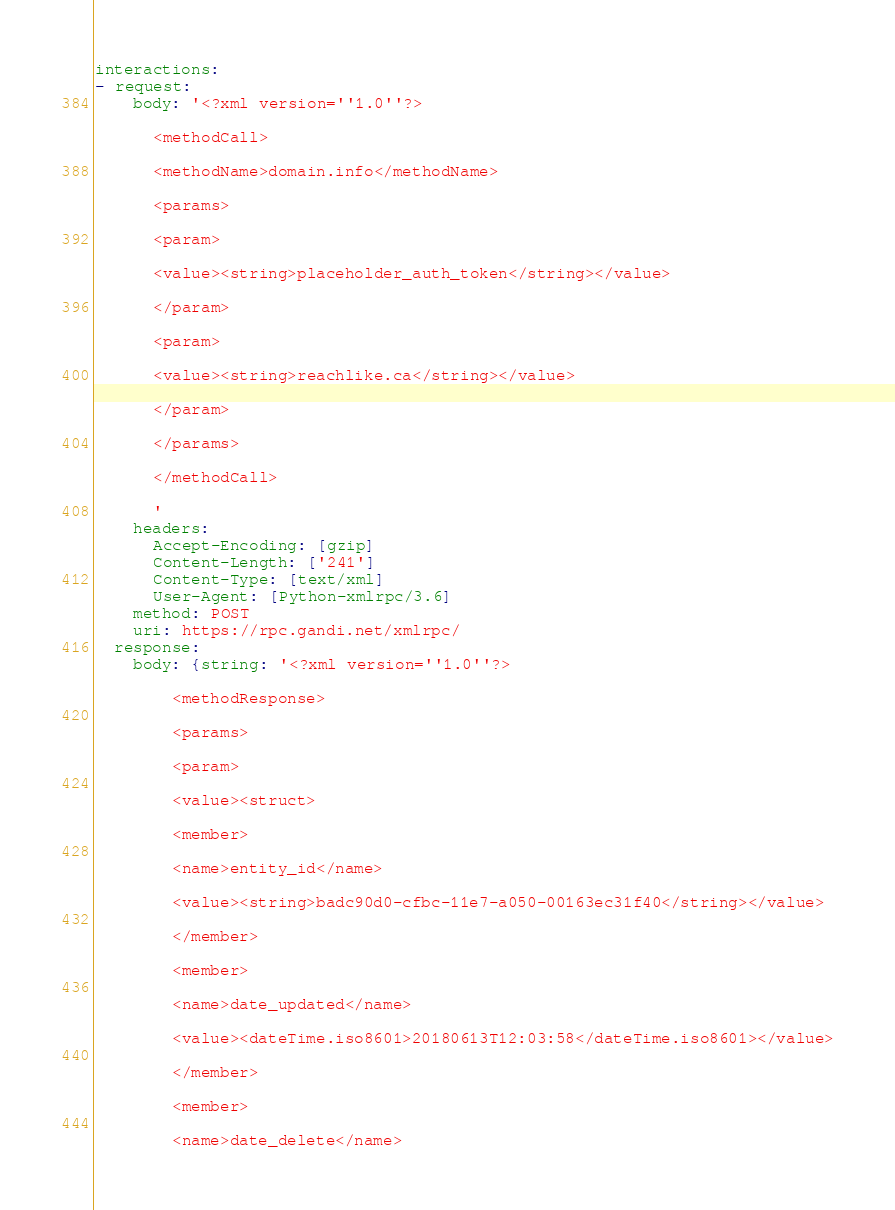Convert code to text. <code><loc_0><loc_0><loc_500><loc_500><_YAML_>interactions:
- request:
    body: '<?xml version=''1.0''?>

      <methodCall>

      <methodName>domain.info</methodName>

      <params>

      <param>

      <value><string>placeholder_auth_token</string></value>

      </param>

      <param>

      <value><string>reachlike.ca</string></value>

      </param>

      </params>

      </methodCall>

      '
    headers:
      Accept-Encoding: [gzip]
      Content-Length: ['241']
      Content-Type: [text/xml]
      User-Agent: [Python-xmlrpc/3.6]
    method: POST
    uri: https://rpc.gandi.net/xmlrpc/
  response:
    body: {string: '<?xml version=''1.0''?>

        <methodResponse>

        <params>

        <param>

        <value><struct>

        <member>

        <name>entity_id</name>

        <value><string>badc90d0-cfbc-11e7-a050-00163ec31f40</string></value>

        </member>

        <member>

        <name>date_updated</name>

        <value><dateTime.iso8601>20180613T12:03:58</dateTime.iso8601></value>

        </member>

        <member>

        <name>date_delete</name>
</code> 